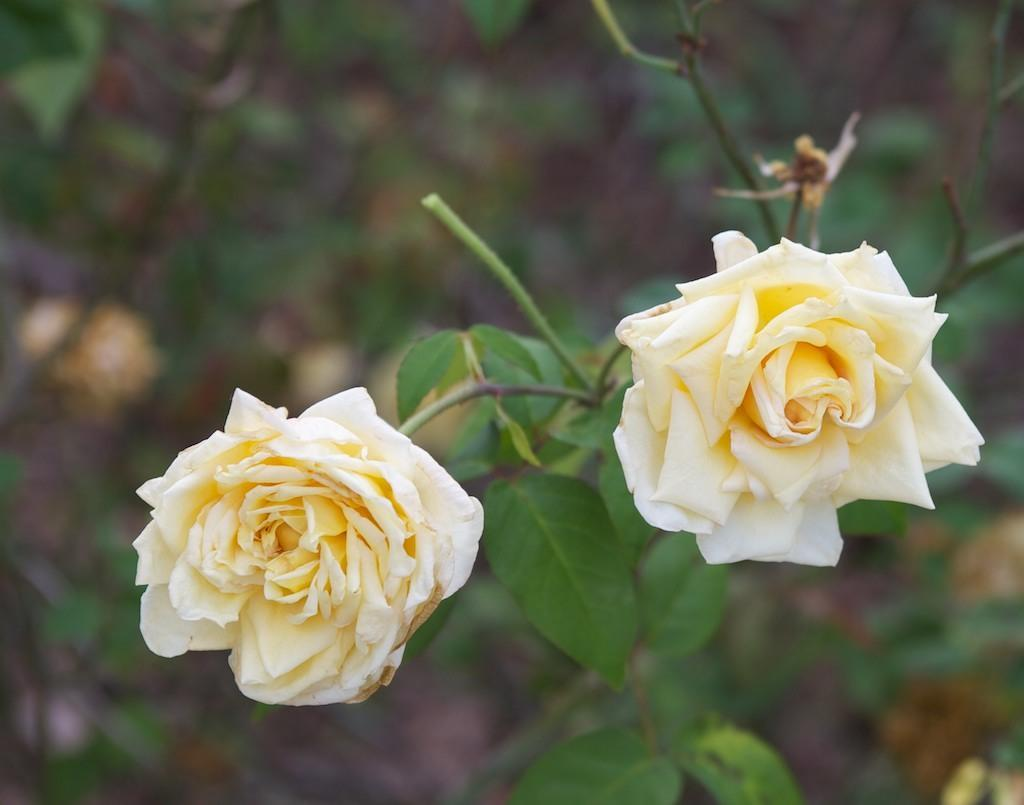What type of plant material is present in the image? There are leaves in the image. What type of flowers can be seen in the image? There are white-colored flowers in the image. How would you describe the clarity of the image's background? The image is blurry in the background. How many cows are drinking milk from the white-colored flowers in the image? There are no cows or milk present in the image; it features leaves and white-colored flowers. 